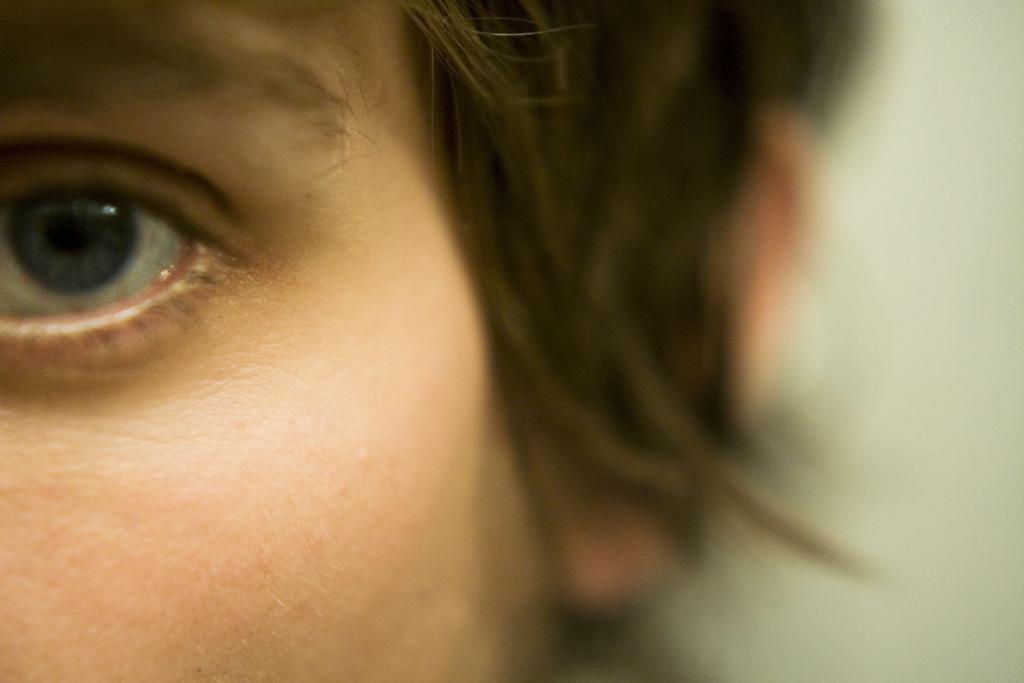How would you summarize this image in a sentence or two? In this image, on the left side, we can see face of a person. On the right side, we can see white color. 